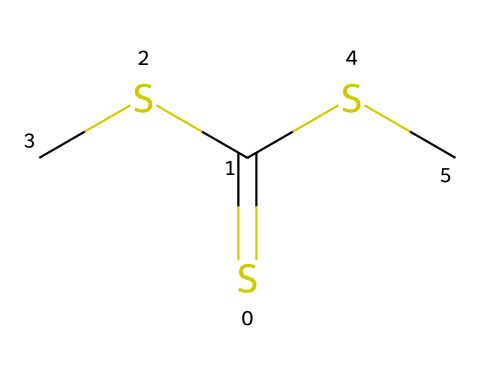What is the name of this chemical? The chemical is called dimethyl thioformate, which can be identified from its structure featuring sulfur (S) and a thioester functional group combined with methyl groups.
Answer: dimethyl thioformate How many sulfur atoms are present in the molecule? The SMILES representation indicates there are three sulfur atoms, as denoted by the three "S" characters, including one in a double bond (S=C) and two in thioether linkages (SC).
Answer: three What is the oxidation state of the sulfur atoms in this chemical? In dimethyl thioformate, one sulfur is in the +4 oxidation state (due to being double-bonded to carbon) and the others are in the -2 oxidation state (as they are bonded with carbons and hydrogens).
Answer: +4 and -2 Is this compound considered a natural pesticide? Dimethyl thioformate is known for its pest-repellent properties, often classified as a natural pesticide used in organic farming, particularly for its effectiveness against pests in vineyards.
Answer: yes What type of functional groups are present in this chemical? The molecule contains thioester (from S=C) and thioether groups (from SC), which are characteristic of sulfur-containing organic compounds used for their pesticidal properties.
Answer: thioester and thioether How many carbon atoms are in this molecule? The chemical structure shows a total of two carbon atoms, represented by the two "C" characters in the SMILES notation.
Answer: two 